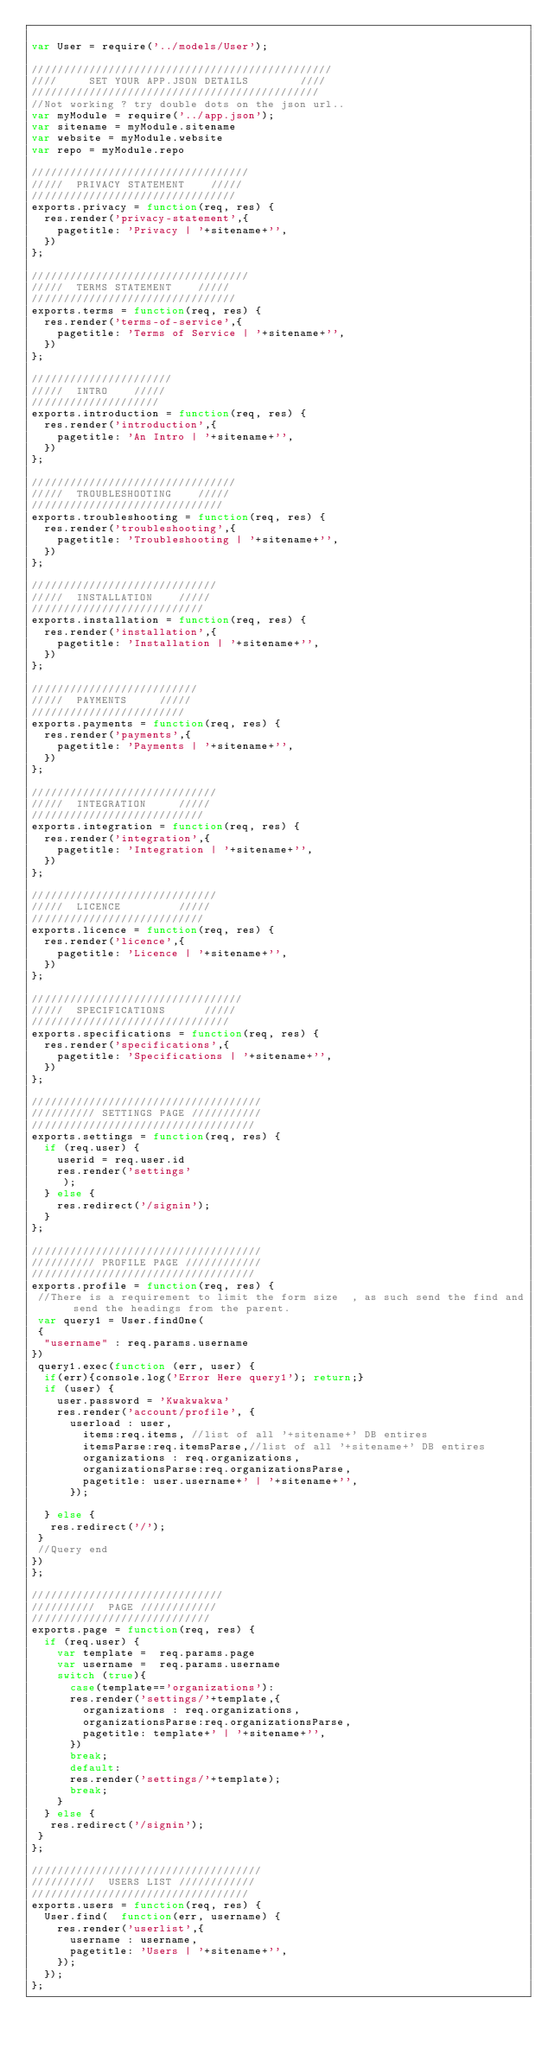Convert code to text. <code><loc_0><loc_0><loc_500><loc_500><_JavaScript_> 
var User = require('../models/User');

///////////////////////////////////////////////
////     SET YOUR APP.JSON DETAILS        //// 
/////////////////////////////////////////////
//Not working ? try double dots on the json url..
var myModule = require('../app.json');
var sitename = myModule.sitename
var website = myModule.website
var repo = myModule.repo

//////////////////////////////////
/////  PRIVACY STATEMENT    ///// 
////////////////////////////////
exports.privacy = function(req, res) {
  res.render('privacy-statement',{
    pagetitle: 'Privacy | '+sitename+'',
  })
}; 

//////////////////////////////////
/////  TERMS STATEMENT    ///// 
////////////////////////////////
exports.terms = function(req, res) {
  res.render('terms-of-service',{
    pagetitle: 'Terms of Service | '+sitename+'',
  })
}; 

//////////////////////
/////  INTRO    ///// 
////////////////////
exports.introduction = function(req, res) {
  res.render('introduction',{
    pagetitle: 'An Intro | '+sitename+'',
  })
}; 

////////////////////////////////
/////  TROUBLESHOOTING    ///// 
//////////////////////////////
exports.troubleshooting = function(req, res) {
  res.render('troubleshooting',{
    pagetitle: 'Troubleshooting | '+sitename+'',
  })
}; 

/////////////////////////////
/////  INSTALLATION    ///// 
///////////////////////////
exports.installation = function(req, res) {
  res.render('installation',{
    pagetitle: 'Installation | '+sitename+'',
  })
};

//////////////////////////
/////  PAYMENTS     ///// 
////////////////////////
exports.payments = function(req, res) {
  res.render('payments',{
    pagetitle: 'Payments | '+sitename+'',
  })
};

/////////////////////////////
/////  INTEGRATION     ///// 
///////////////////////////
exports.integration = function(req, res) {
  res.render('integration',{
    pagetitle: 'Integration | '+sitename+'',
  })
};

/////////////////////////////
/////  LICENCE         ///// 
///////////////////////////
exports.licence = function(req, res) {
  res.render('licence',{
    pagetitle: 'Licence | '+sitename+'',
  })
};

/////////////////////////////////
/////  SPECIFICATIONS      ///// 
///////////////////////////////
exports.specifications = function(req, res) {
  res.render('specifications',{
    pagetitle: 'Specifications | '+sitename+'',
  })
};

////////////////////////////////////
////////// SETTINGS PAGE ///////////
///////////////////////////////////
exports.settings = function(req, res) {
	if (req.user) {
		userid = req.user.id
		res.render('settings'
     );
	} else {
		res.redirect('/signin');
	}
};

////////////////////////////////////
////////// PROFILE PAGE ////////////
///////////////////////////////////
exports.profile = function(req, res) {
 //There is a requirement to limit the form size  , as such send the find and send the headings from the parent.
 var query1 = User.findOne(
 {
  "username" : req.params.username
})
 query1.exec(function (err, user) { 
  if(err){console.log('Error Here query1'); return;}
  if (user) {
    user.password = 'Kwakwakwa'
    res.render('account/profile', {
      userload : user,
        items:req.items, //list of all '+sitename+' DB entires
        itemsParse:req.itemsParse,//list of all '+sitename+' DB entires
        organizations : req.organizations,
        organizationsParse:req.organizationsParse,
        pagetitle: user.username+' | '+sitename+'',
      });

  } else {
   res.redirect('/');
 }
 //Query end
})
};

//////////////////////////////
//////////  PAGE ////////////
////////////////////////////
exports.page = function(req, res) {
  if (req.user) {
    var template =  req.params.page 
    var username =  req.params.username 
    switch (true){
      case(template=='organizations'):
      res.render('settings/'+template,{
        organizations : req.organizations,
        organizationsParse:req.organizationsParse,
        pagetitle: template+' | '+sitename+'',
      })
      break;
      default:
      res.render('settings/'+template);
      break;
    }
  } else {
   res.redirect('/signin');
 }
};

////////////////////////////////////
//////////  USERS LIST ////////////
//////////////////////////////////
exports.users = function(req, res) {
  User.find(  function(err, username) {
    res.render('userlist',{
      username : username,
      pagetitle: 'Users | '+sitename+'',
    });
  });
};


</code> 